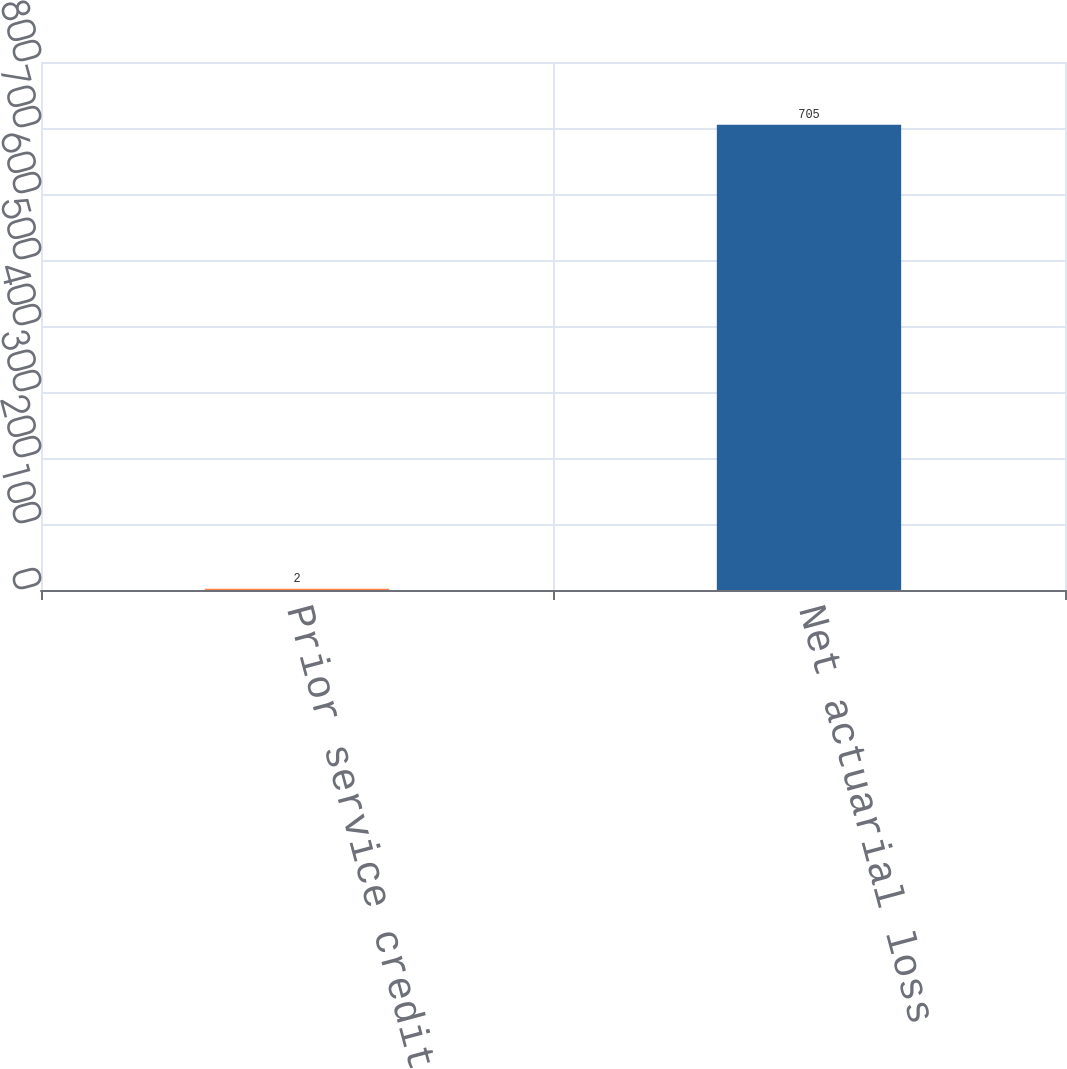Convert chart. <chart><loc_0><loc_0><loc_500><loc_500><bar_chart><fcel>Prior service credits<fcel>Net actuarial loss<nl><fcel>2<fcel>705<nl></chart> 